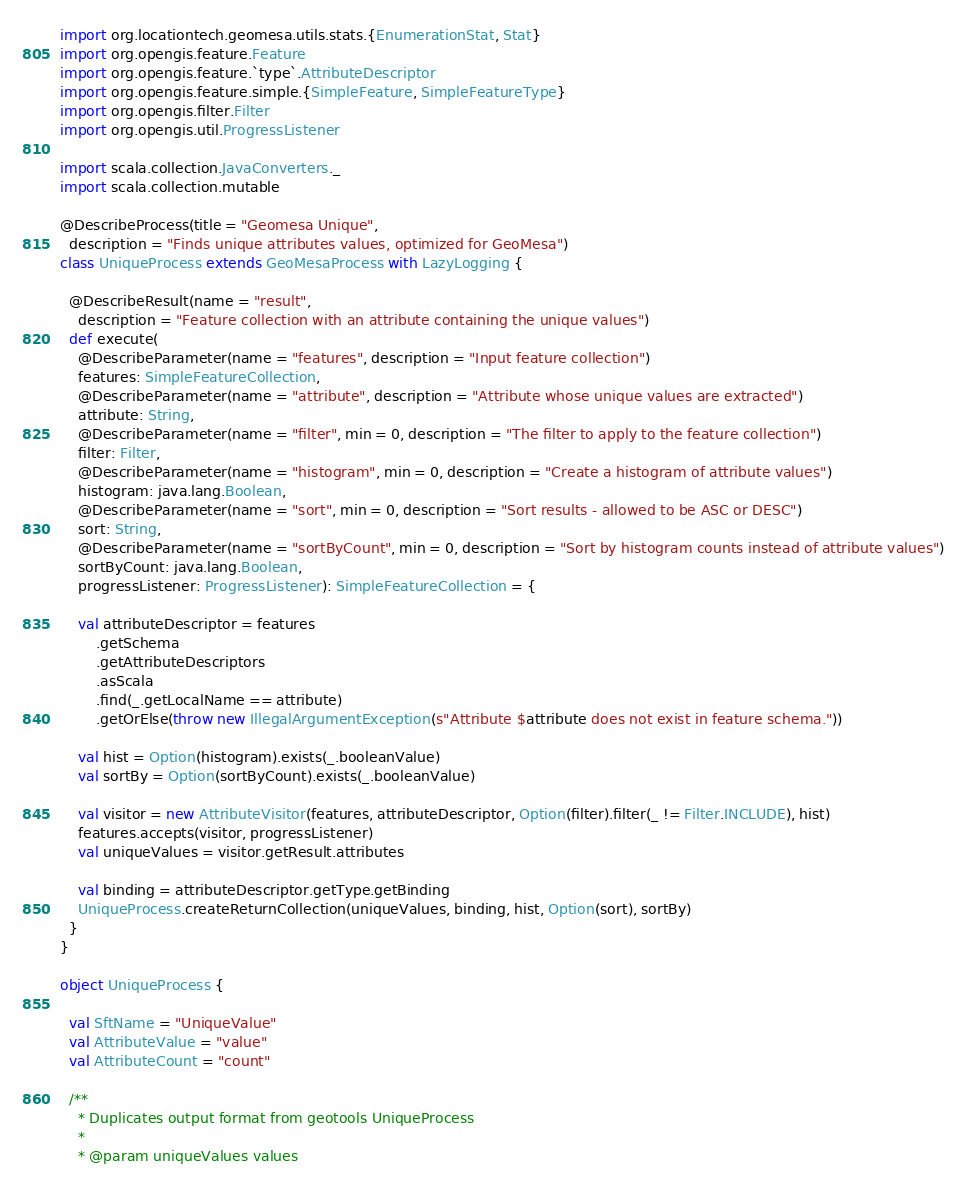Convert code to text. <code><loc_0><loc_0><loc_500><loc_500><_Scala_>import org.locationtech.geomesa.utils.stats.{EnumerationStat, Stat}
import org.opengis.feature.Feature
import org.opengis.feature.`type`.AttributeDescriptor
import org.opengis.feature.simple.{SimpleFeature, SimpleFeatureType}
import org.opengis.filter.Filter
import org.opengis.util.ProgressListener

import scala.collection.JavaConverters._
import scala.collection.mutable

@DescribeProcess(title = "Geomesa Unique",
  description = "Finds unique attributes values, optimized for GeoMesa")
class UniqueProcess extends GeoMesaProcess with LazyLogging {

  @DescribeResult(name = "result",
    description = "Feature collection with an attribute containing the unique values")
  def execute(
    @DescribeParameter(name = "features", description = "Input feature collection")
    features: SimpleFeatureCollection,
    @DescribeParameter(name = "attribute", description = "Attribute whose unique values are extracted")
    attribute: String,
    @DescribeParameter(name = "filter", min = 0, description = "The filter to apply to the feature collection")
    filter: Filter,
    @DescribeParameter(name = "histogram", min = 0, description = "Create a histogram of attribute values")
    histogram: java.lang.Boolean,
    @DescribeParameter(name = "sort", min = 0, description = "Sort results - allowed to be ASC or DESC")
    sort: String,
    @DescribeParameter(name = "sortByCount", min = 0, description = "Sort by histogram counts instead of attribute values")
    sortByCount: java.lang.Boolean,
    progressListener: ProgressListener): SimpleFeatureCollection = {

    val attributeDescriptor = features
        .getSchema
        .getAttributeDescriptors
        .asScala
        .find(_.getLocalName == attribute)
        .getOrElse(throw new IllegalArgumentException(s"Attribute $attribute does not exist in feature schema."))

    val hist = Option(histogram).exists(_.booleanValue)
    val sortBy = Option(sortByCount).exists(_.booleanValue)

    val visitor = new AttributeVisitor(features, attributeDescriptor, Option(filter).filter(_ != Filter.INCLUDE), hist)
    features.accepts(visitor, progressListener)
    val uniqueValues = visitor.getResult.attributes

    val binding = attributeDescriptor.getType.getBinding
    UniqueProcess.createReturnCollection(uniqueValues, binding, hist, Option(sort), sortBy)
  }
}

object UniqueProcess {

  val SftName = "UniqueValue"
  val AttributeValue = "value"
  val AttributeCount = "count"

  /**
    * Duplicates output format from geotools UniqueProcess
    *
    * @param uniqueValues values</code> 